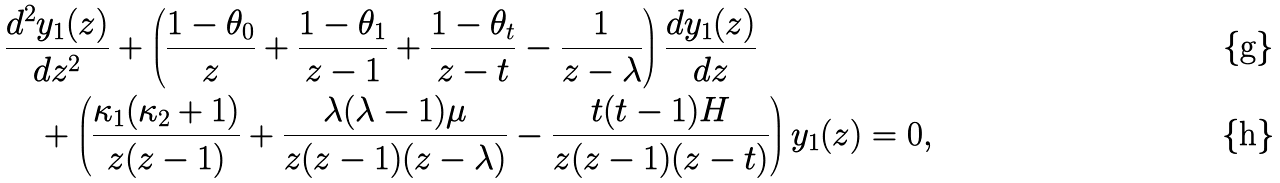Convert formula to latex. <formula><loc_0><loc_0><loc_500><loc_500>& \frac { d ^ { 2 } y _ { 1 } ( z ) } { d z ^ { 2 } } + \left ( \frac { 1 - \theta _ { 0 } } { z } + \frac { 1 - \theta _ { 1 } } { z - 1 } + \frac { 1 - \theta _ { t } } { z - t } - \frac { 1 } { z - \lambda } \right ) \frac { d y _ { 1 } ( z ) } { d z } \\ & \quad + \left ( \frac { \kappa _ { 1 } ( \kappa _ { 2 } + 1 ) } { z ( z - 1 ) } + \frac { \lambda ( \lambda - 1 ) \mu } { z ( z - 1 ) ( z - \lambda ) } - \frac { t ( t - 1 ) H } { z ( z - 1 ) ( z - t ) } \right ) y _ { 1 } ( z ) = 0 ,</formula> 